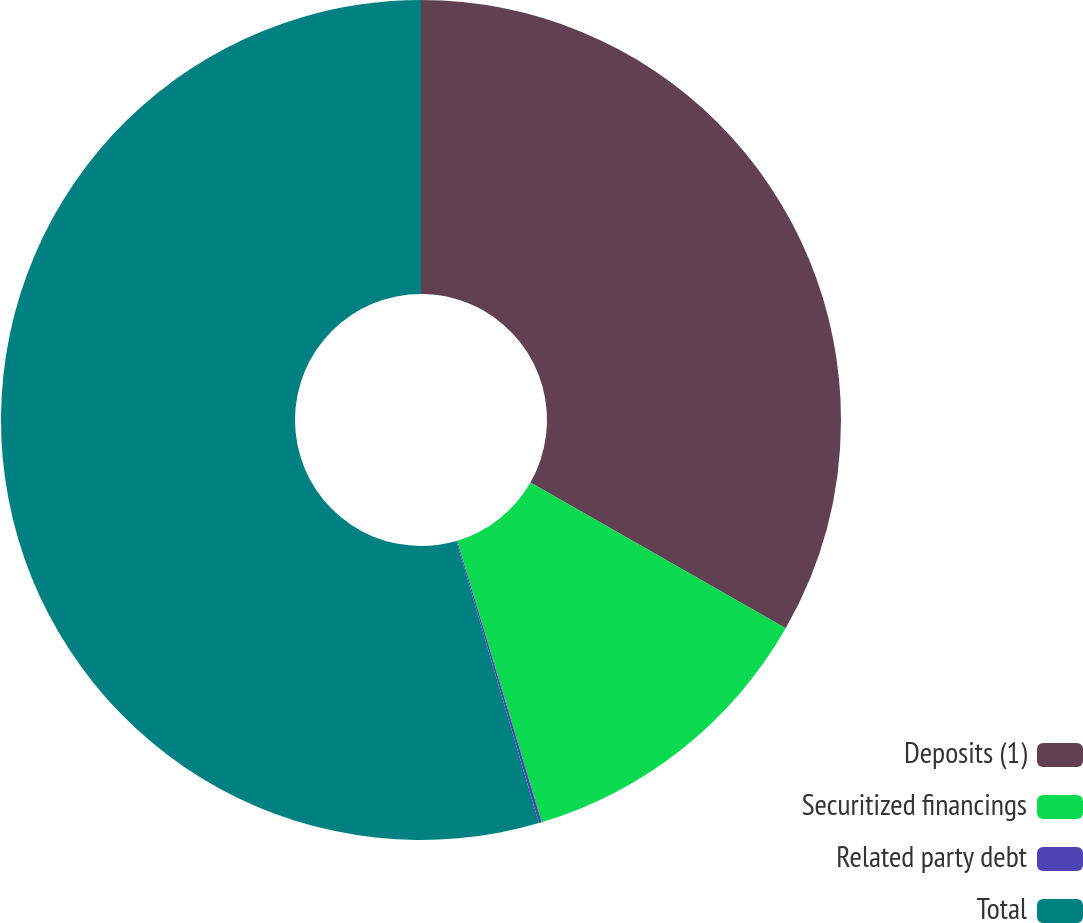Convert chart to OTSL. <chart><loc_0><loc_0><loc_500><loc_500><pie_chart><fcel>Deposits (1)<fcel>Securitized financings<fcel>Related party debt<fcel>Total<nl><fcel>33.26%<fcel>12.1%<fcel>0.11%<fcel>54.53%<nl></chart> 